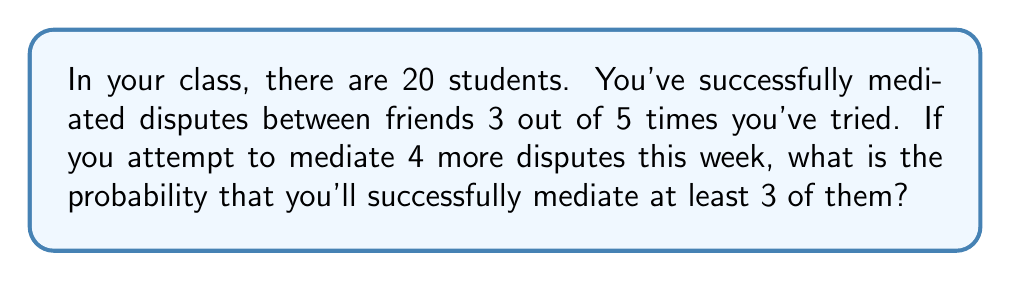Teach me how to tackle this problem. Let's approach this step-by-step:

1) First, we need to identify the probability of success for a single mediation attempt. From the given information:
   $P(\text{success}) = \frac{3}{5} = 0.6$

2) This scenario follows a binomial probability distribution. We want to find the probability of at least 3 successes out of 4 attempts.

3) The probability of exactly $k$ successes in $n$ trials is given by the binomial probability formula:

   $P(X = k) = \binom{n}{k} p^k (1-p)^{n-k}$

   Where:
   $n$ is the number of trials (4 in this case)
   $k$ is the number of successes
   $p$ is the probability of success on a single trial (0.6)

4) We need to calculate $P(X \geq 3) = P(X = 3) + P(X = 4)$

5) For 3 successes:
   $P(X = 3) = \binom{4}{3} (0.6)^3 (0.4)^1 = 4 \times 0.216 \times 0.4 = 0.3456$

6) For 4 successes:
   $P(X = 4) = \binom{4}{4} (0.6)^4 (0.4)^0 = 1 \times 0.1296 \times 1 = 0.1296$

7) Therefore, the probability of at least 3 successes is:
   $P(X \geq 3) = 0.3456 + 0.1296 = 0.4752$
Answer: 0.4752 